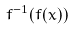Convert formula to latex. <formula><loc_0><loc_0><loc_500><loc_500>f ^ { - 1 } ( f ( x ) )</formula> 